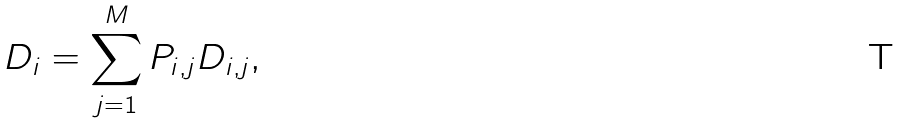Convert formula to latex. <formula><loc_0><loc_0><loc_500><loc_500>D _ { i } = \sum _ { j = 1 } ^ { M } P _ { i , j } D _ { i , j } ,</formula> 